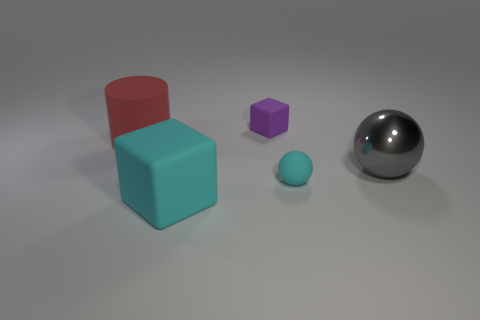Add 3 small purple matte balls. How many objects exist? 8 Subtract all gray balls. How many balls are left? 1 Subtract 1 cylinders. How many cylinders are left? 0 Subtract all red balls. Subtract all purple cylinders. How many balls are left? 2 Subtract all spheres. How many objects are left? 3 Subtract all blue spheres. How many blue blocks are left? 0 Subtract all large rubber objects. Subtract all big shiny balls. How many objects are left? 2 Add 4 tiny matte things. How many tiny matte things are left? 6 Add 3 gray metallic balls. How many gray metallic balls exist? 4 Subtract 1 purple cubes. How many objects are left? 4 